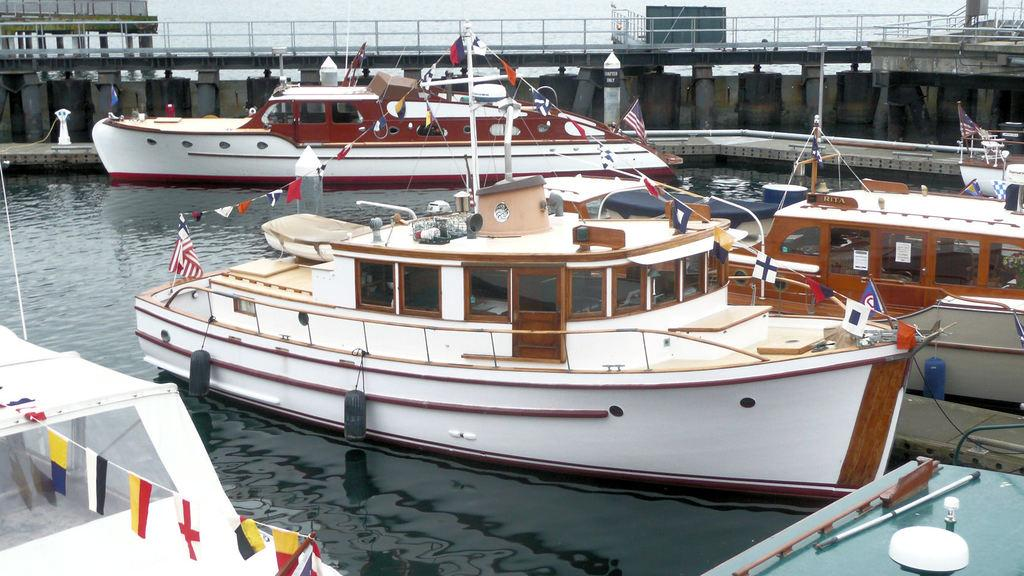What is in the water in the image? There are boats in the water in the image. What can be seen flying in the image? Flags are visible in the image. What structure is present in the image? There is a bridge in the image. What architectural elements are part of the bridge? There are pillars in the image. What type of wool is being used to make the airplane in the image? There is no airplane present in the image, and therefore no wool is being used to make one. What class of students is depicted in the image? There is no reference to students or a class in the image. 